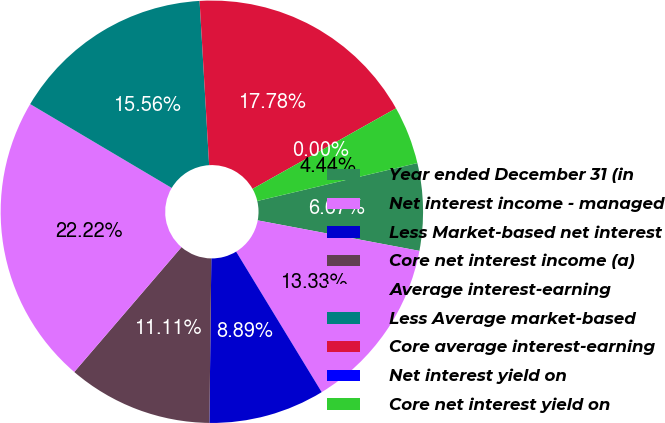Convert chart to OTSL. <chart><loc_0><loc_0><loc_500><loc_500><pie_chart><fcel>Year ended December 31 (in<fcel>Net interest income - managed<fcel>Less Market-based net interest<fcel>Core net interest income (a)<fcel>Average interest-earning<fcel>Less Average market-based<fcel>Core average interest-earning<fcel>Net interest yield on<fcel>Core net interest yield on<nl><fcel>6.67%<fcel>13.33%<fcel>8.89%<fcel>11.11%<fcel>22.22%<fcel>15.56%<fcel>17.78%<fcel>0.0%<fcel>4.44%<nl></chart> 